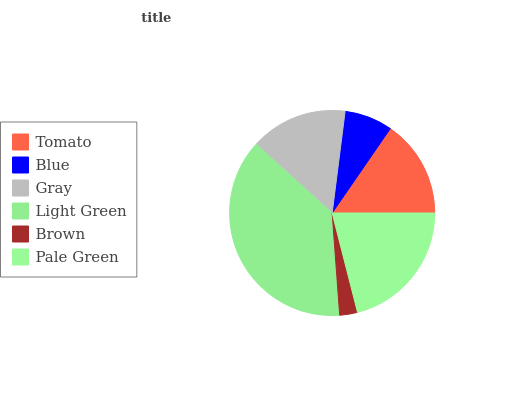Is Brown the minimum?
Answer yes or no. Yes. Is Light Green the maximum?
Answer yes or no. Yes. Is Blue the minimum?
Answer yes or no. No. Is Blue the maximum?
Answer yes or no. No. Is Tomato greater than Blue?
Answer yes or no. Yes. Is Blue less than Tomato?
Answer yes or no. Yes. Is Blue greater than Tomato?
Answer yes or no. No. Is Tomato less than Blue?
Answer yes or no. No. Is Tomato the high median?
Answer yes or no. Yes. Is Gray the low median?
Answer yes or no. Yes. Is Light Green the high median?
Answer yes or no. No. Is Brown the low median?
Answer yes or no. No. 